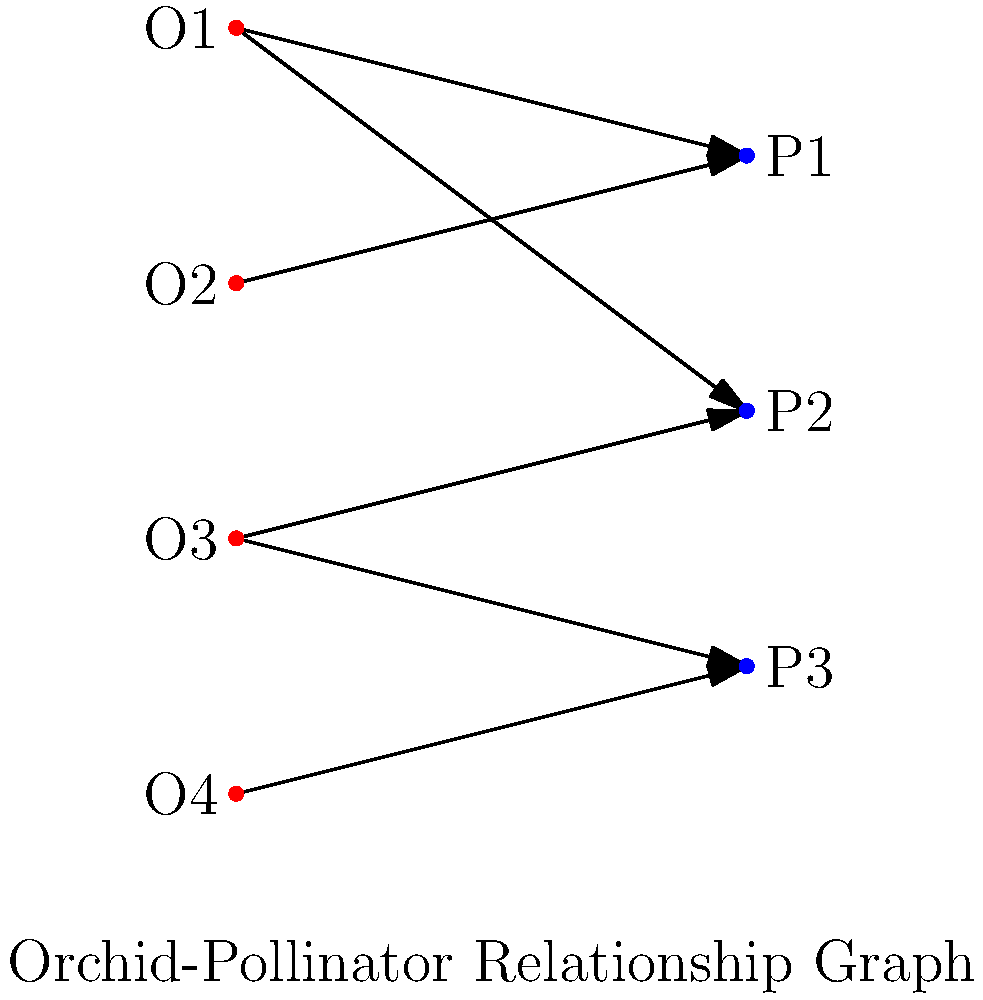In the bipartite graph representing orchid-pollinator relationships, which orchid species has the highest degree centrality, and what does this imply about its ecological role in the Thai orchid ecosystem? To answer this question, we need to follow these steps:

1. Understand degree centrality: In a bipartite graph, degree centrality for a node is the number of edges connected to it.

2. Count the connections for each orchid:
   O1: 2 connections (to P1 and P2)
   O2: 1 connection (to P1)
   O3: 2 connections (to P2 and P3)
   O4: 1 connection (to P3)

3. Identify the orchid with the highest degree centrality:
   O1 and O3 both have the highest degree centrality with 2 connections each.

4. Interpret the ecological implications:
   - Higher degree centrality suggests these orchids interact with more pollinator species.
   - This implies a more generalist pollination strategy.
   - These orchids may have a higher chance of successful pollination due to multiple pollinator options.
   - They might play a crucial role in maintaining the overall stability of the pollination network in the Thai orchid ecosystem.

5. Consider the local context:
   As an orchid enthusiast from Thailand, you would recognize that orchids with higher degree centrality are likely more resilient to changes in pollinator populations, which is crucial for conservation efforts of unique local varieties.
Answer: O1 and O3; more generalist strategy and higher ecological resilience 